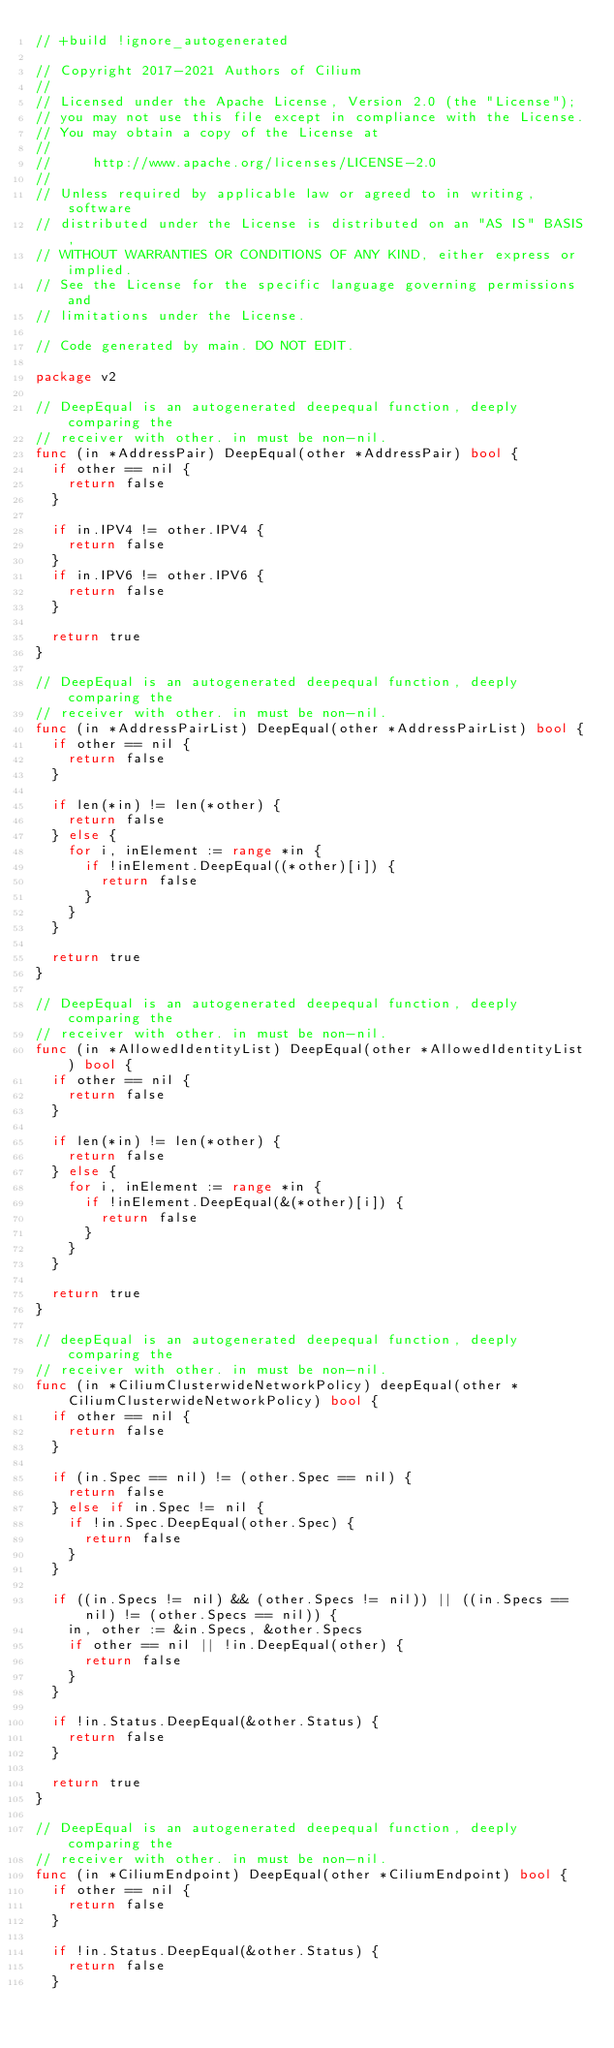<code> <loc_0><loc_0><loc_500><loc_500><_Go_>// +build !ignore_autogenerated

// Copyright 2017-2021 Authors of Cilium
//
// Licensed under the Apache License, Version 2.0 (the "License");
// you may not use this file except in compliance with the License.
// You may obtain a copy of the License at
//
//     http://www.apache.org/licenses/LICENSE-2.0
//
// Unless required by applicable law or agreed to in writing, software
// distributed under the License is distributed on an "AS IS" BASIS,
// WITHOUT WARRANTIES OR CONDITIONS OF ANY KIND, either express or implied.
// See the License for the specific language governing permissions and
// limitations under the License.

// Code generated by main. DO NOT EDIT.

package v2

// DeepEqual is an autogenerated deepequal function, deeply comparing the
// receiver with other. in must be non-nil.
func (in *AddressPair) DeepEqual(other *AddressPair) bool {
	if other == nil {
		return false
	}

	if in.IPV4 != other.IPV4 {
		return false
	}
	if in.IPV6 != other.IPV6 {
		return false
	}

	return true
}

// DeepEqual is an autogenerated deepequal function, deeply comparing the
// receiver with other. in must be non-nil.
func (in *AddressPairList) DeepEqual(other *AddressPairList) bool {
	if other == nil {
		return false
	}

	if len(*in) != len(*other) {
		return false
	} else {
		for i, inElement := range *in {
			if !inElement.DeepEqual((*other)[i]) {
				return false
			}
		}
	}

	return true
}

// DeepEqual is an autogenerated deepequal function, deeply comparing the
// receiver with other. in must be non-nil.
func (in *AllowedIdentityList) DeepEqual(other *AllowedIdentityList) bool {
	if other == nil {
		return false
	}

	if len(*in) != len(*other) {
		return false
	} else {
		for i, inElement := range *in {
			if !inElement.DeepEqual(&(*other)[i]) {
				return false
			}
		}
	}

	return true
}

// deepEqual is an autogenerated deepequal function, deeply comparing the
// receiver with other. in must be non-nil.
func (in *CiliumClusterwideNetworkPolicy) deepEqual(other *CiliumClusterwideNetworkPolicy) bool {
	if other == nil {
		return false
	}

	if (in.Spec == nil) != (other.Spec == nil) {
		return false
	} else if in.Spec != nil {
		if !in.Spec.DeepEqual(other.Spec) {
			return false
		}
	}

	if ((in.Specs != nil) && (other.Specs != nil)) || ((in.Specs == nil) != (other.Specs == nil)) {
		in, other := &in.Specs, &other.Specs
		if other == nil || !in.DeepEqual(other) {
			return false
		}
	}

	if !in.Status.DeepEqual(&other.Status) {
		return false
	}

	return true
}

// DeepEqual is an autogenerated deepequal function, deeply comparing the
// receiver with other. in must be non-nil.
func (in *CiliumEndpoint) DeepEqual(other *CiliumEndpoint) bool {
	if other == nil {
		return false
	}

	if !in.Status.DeepEqual(&other.Status) {
		return false
	}
</code> 